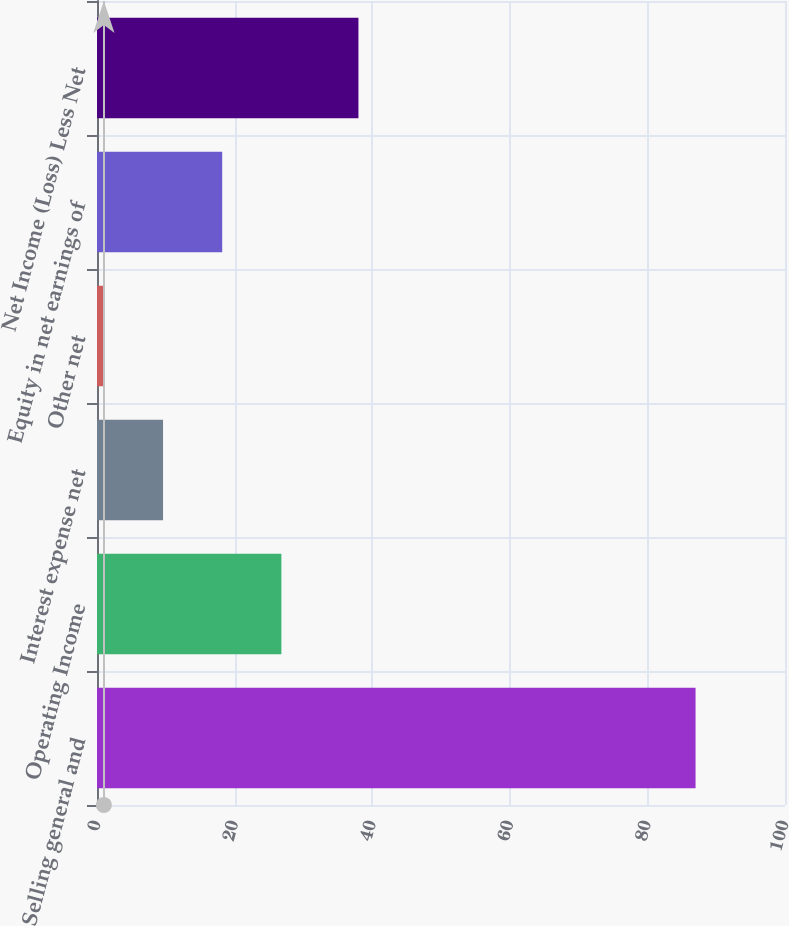Convert chart to OTSL. <chart><loc_0><loc_0><loc_500><loc_500><bar_chart><fcel>Selling general and<fcel>Operating Income<fcel>Interest expense net<fcel>Other net<fcel>Equity in net earnings of<fcel>Net Income (Loss) Less Net<nl><fcel>87<fcel>26.8<fcel>9.6<fcel>1<fcel>18.2<fcel>38<nl></chart> 